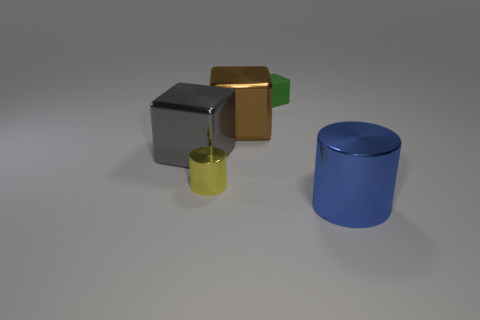What might be the context or purpose of this group of objects? This image seems to be a digital render, possibly serving an illustrative purpose, for example, to showcase different materials and reflections for computer graphics training or as a test for lighting and shading effects in a 3D modeling software. 